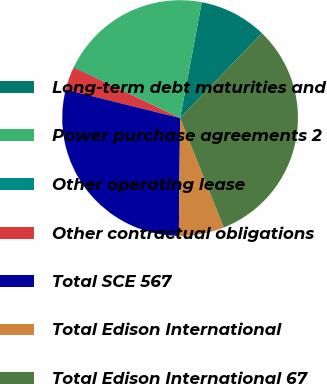Convert chart. <chart><loc_0><loc_0><loc_500><loc_500><pie_chart><fcel>Long-term debt maturities and<fcel>Power purchase agreements 2<fcel>Other operating lease<fcel>Other contractual obligations<fcel>Total SCE 567<fcel>Total Edison International<fcel>Total Edison International 67<nl><fcel>9.26%<fcel>20.75%<fcel>0.14%<fcel>3.18%<fcel>28.7%<fcel>6.22%<fcel>31.74%<nl></chart> 